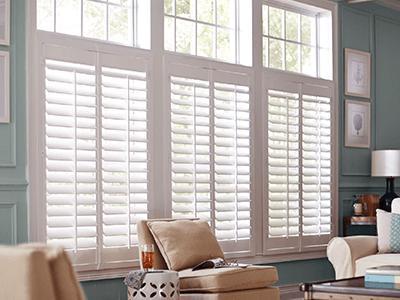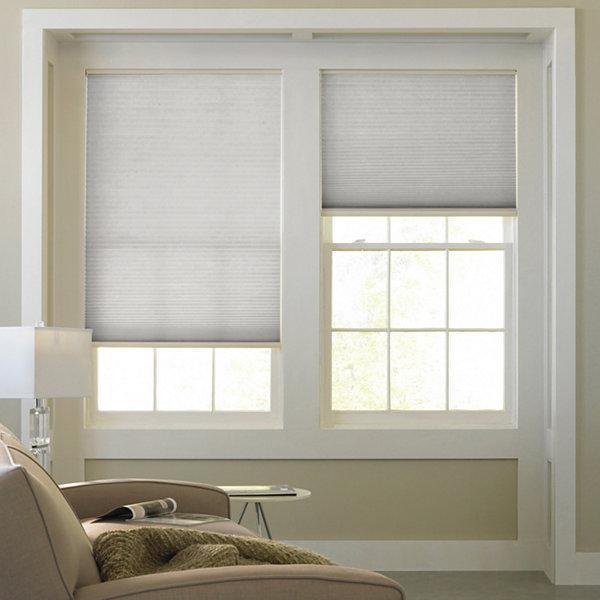The first image is the image on the left, the second image is the image on the right. Examine the images to the left and right. Is the description "The left and right image contains the same number of blinds." accurate? Answer yes or no. No. 